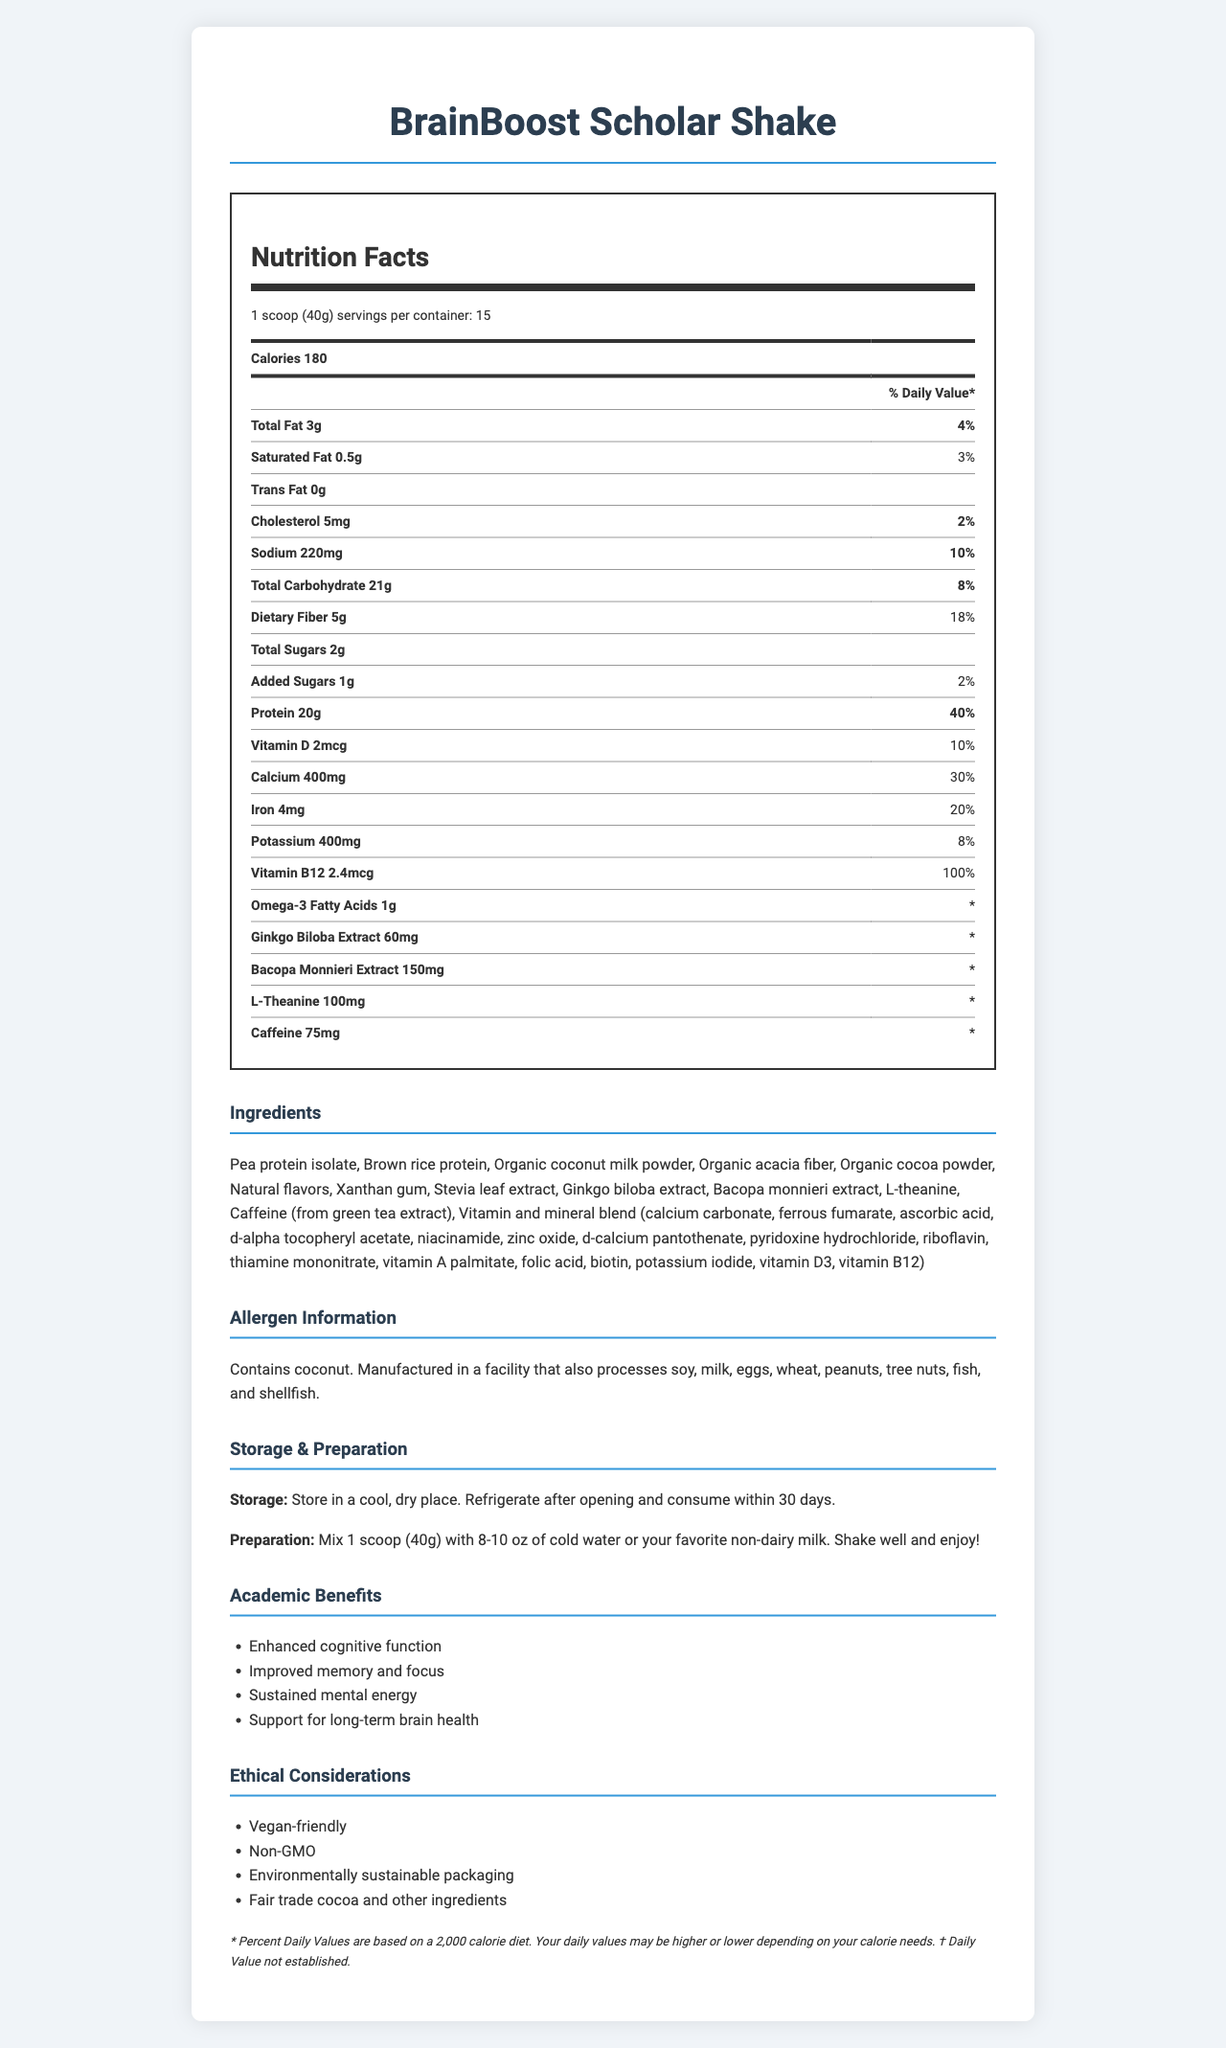what is the serving size for BrainBoost Scholar Shake? The serving size is explicitly mentioned as "1 scoop (40g)" in the document.
Answer: 1 scoop (40g) how many servings are there per container? According to the document, there are 15 servings per container.
Answer: 15 how much protein does one serving provide? The nutrition facts show that one serving provides 20g of protein.
Answer: 20g what percentage of the daily value of calcium does one serving provide? The document indicates that one serving provides 30% of the daily value of calcium.
Answer: 30% which vitamin is present in the highest percentage of daily value? The document states that Vitamin B12 is present at 100% of the daily value.
Answer: Vitamin B12 how much caffeine is present in one serving? The nutrition facts list caffeine content as 75mg per serving.
Answer: 75mg what are the cognitive benefits mentioned for this product? The academic benefits are listed under the "Academic Benefits" section of the document.
Answer: Enhanced cognitive function, Improved memory and focus, Sustained mental energy, Support for long-term brain health A serving of the meal replacement shake contains: A. 5g total sugars B. 2g total sugars C. 1g total sugars The document explicitly states that the shake contains 2g of total sugars.
Answer: B what is the storage instruction for BrainBoost Scholar Shake? The storage instructions are provided in the document under the "Storage & Preparation" section.
Answer: Store in a cool, dry place. Refrigerate after opening and consume within 30 days. True or False: The product contains no saturated fat. The document indicates that each serving contains 0.5g of saturated fat.
Answer: False which ingredient is not listed in BrainBoost Scholar Shake? A. Pea protein isolate B. Milk protein isolate C. Organic coconut milk powder The ingredient list does not mention "Milk protein isolate"; it mentions "Pea protein isolate" and "Organic coconut milk powder".
Answer: B I am allergic to tree nuts. Can I consume BrainBoost Scholar Shake without concern? The allergen information states it is manufactured in a facility that also processes tree nuts.
Answer: No how much total fat does one serving of this shake contain? The total fat content per serving is listed as 3g in the document.
Answer: 3g what is the main idea of the document? The document provides comprehensive details about the BrainBoost Scholar Shake, including its nutritional benefits for cognitive functions, ingredient list, allergen warnings, storage and preparation instructions, as well as ethical considerations.
Answer: BrainBoost Scholar Shake is a meal replacement shake designed for busy academics, emphasizing cognitive benefits with detailed nutrition information, ingredients, allergen info, storage and preparation instructions, and ethical considerations. how many different extracts are included in the BrainBoost Scholar Shake's formula? The document lists Ginkgo Biloba Extract, Bacopa Monnieri Extract, and L-Theanine as the extracts included in the product's formula.
Answer: 3 does one serving of BrainBoost Scholar Shake provide 50% or more of the daily value of any mineral or vitamin? The document indicates that one serving provides 100% of the daily value of Vitamin B12.
Answer: Yes what makes BrainBoost Scholar Shake vegan-friendly? The document states it is vegan-friendly, and the ingredient list shows no animal-derived ingredients.
Answer: It contains no animal-derived ingredients. what is the main source of protein in BrainBoost Scholar Shake? The ingredient list shows that the main sources of protein are Pea protein isolate and Brown rice protein.
Answer: Pea protein isolate and Brown rice protein is there any cholesterol in BrainBoost Scholar Shake? The document lists 5mg of cholesterol per serving.
Answer: Yes who manufactures BrainBoost Scholar Shake? The document does not provide any information about the manufacturer of the BrainBoost Scholar Shake.
Answer: Not enough information 